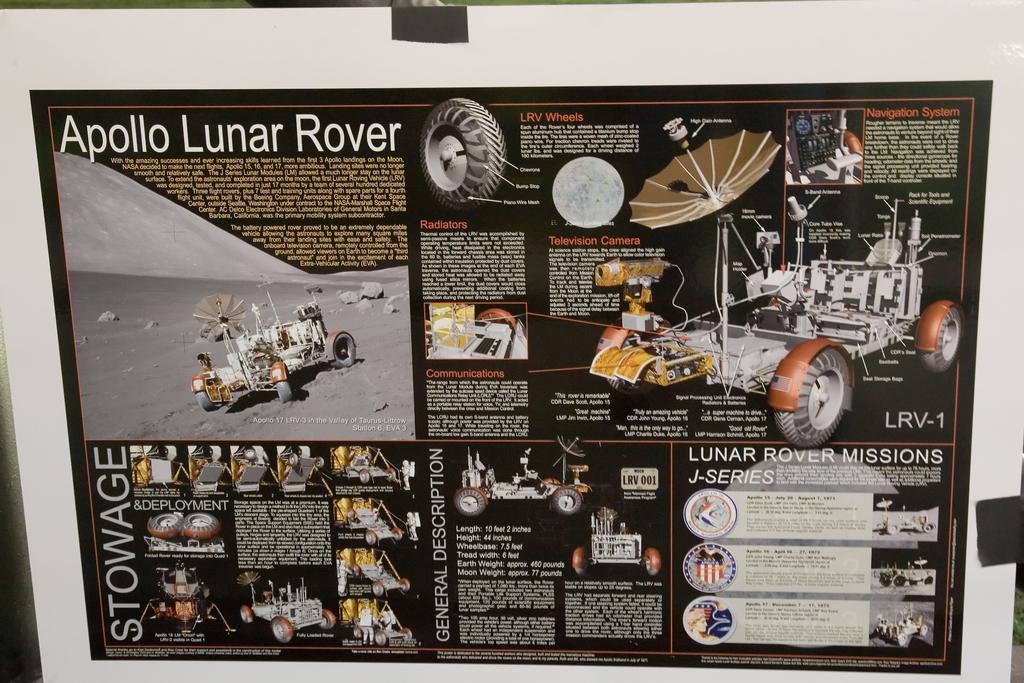What rover is the ad?
Offer a terse response. Apollo lunar rover. What word is vertical on the left page?
Give a very brief answer. Stowage. 